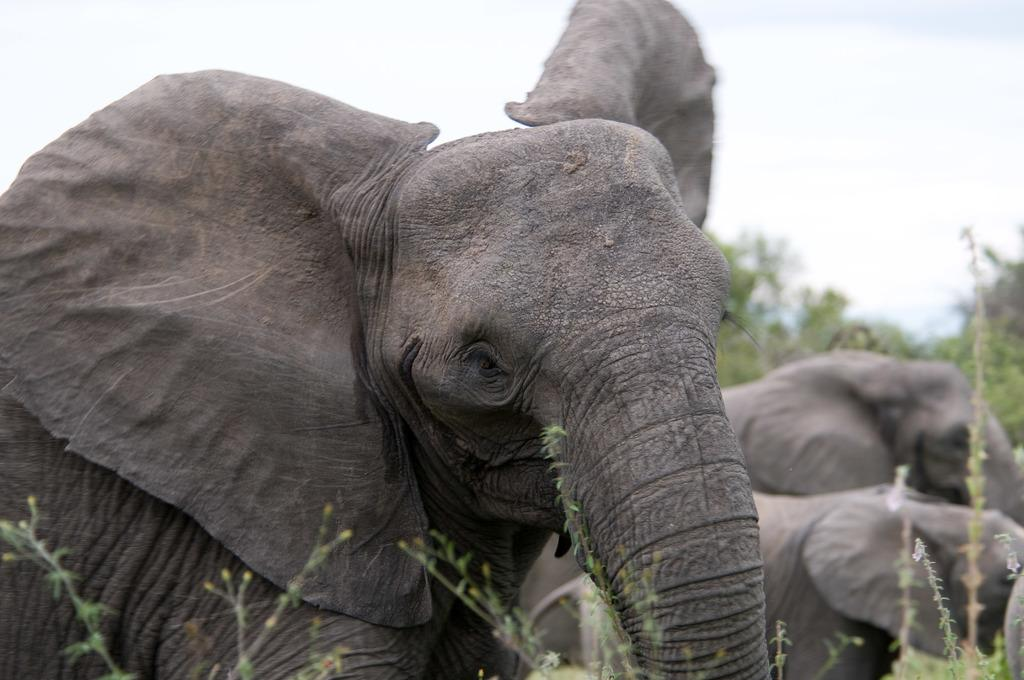What animals are present in the image? There are elephants in the image. What other elements can be seen in the image besides the elephants? There are plants in the image. What can be seen in the background of the image? The sky is visible in the background of the image. What type of reward can be seen hanging from the plants in the image? There are no rewards hanging from the plants in the image; it only features elephants and plants. 